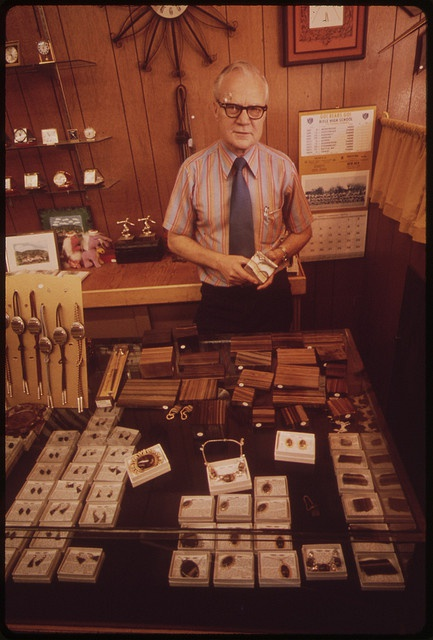Describe the objects in this image and their specific colors. I can see people in black, salmon, brown, and maroon tones, clock in black, maroon, and brown tones, and tie in black, maroon, and brown tones in this image. 